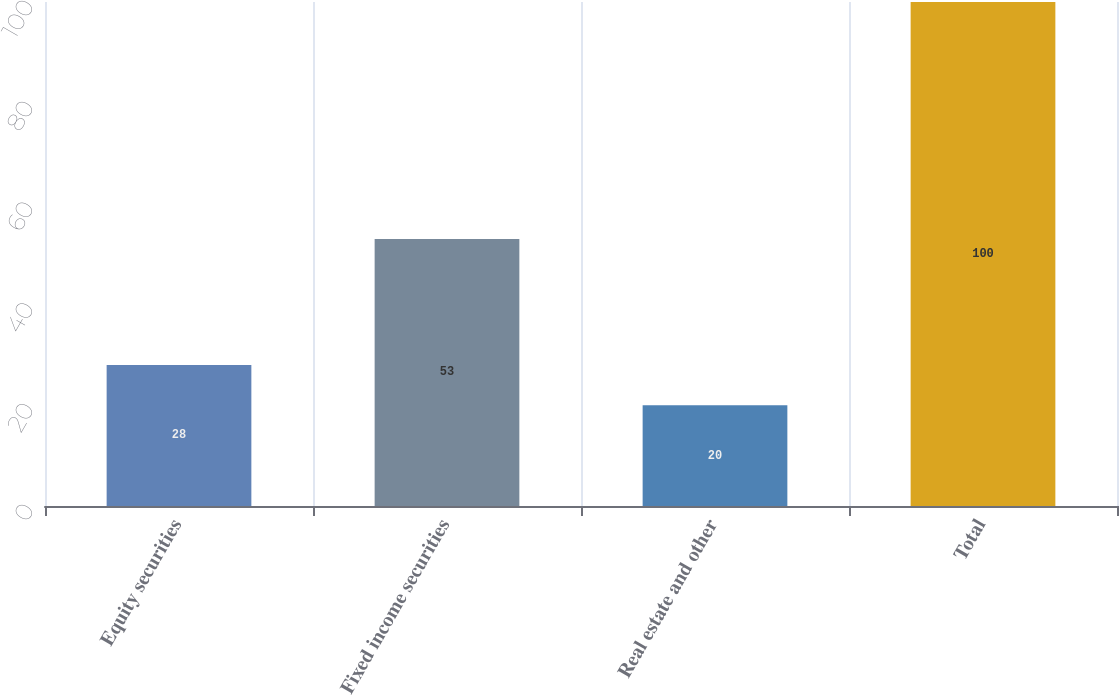Convert chart to OTSL. <chart><loc_0><loc_0><loc_500><loc_500><bar_chart><fcel>Equity securities<fcel>Fixed income securities<fcel>Real estate and other<fcel>Total<nl><fcel>28<fcel>53<fcel>20<fcel>100<nl></chart> 